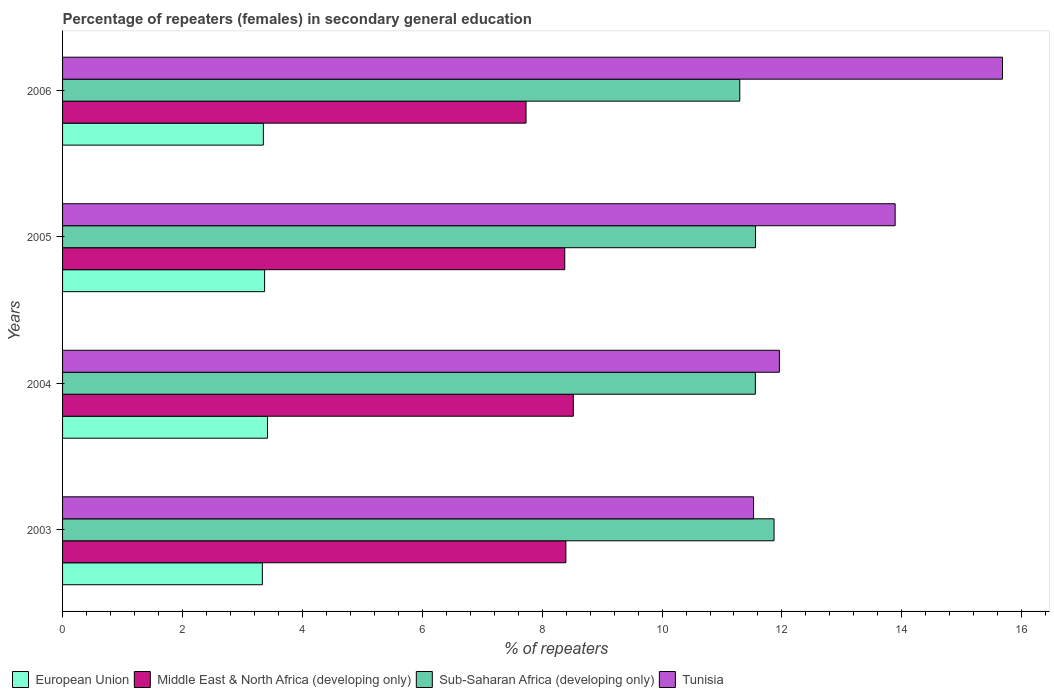How many groups of bars are there?
Keep it short and to the point. 4. How many bars are there on the 4th tick from the top?
Make the answer very short. 4. How many bars are there on the 2nd tick from the bottom?
Give a very brief answer. 4. What is the percentage of female repeaters in Tunisia in 2004?
Provide a short and direct response. 11.96. Across all years, what is the maximum percentage of female repeaters in European Union?
Your answer should be compact. 3.42. Across all years, what is the minimum percentage of female repeaters in Middle East & North Africa (developing only)?
Provide a succinct answer. 7.73. In which year was the percentage of female repeaters in Tunisia minimum?
Provide a short and direct response. 2003. What is the total percentage of female repeaters in Middle East & North Africa (developing only) in the graph?
Offer a very short reply. 33.02. What is the difference between the percentage of female repeaters in Middle East & North Africa (developing only) in 2003 and that in 2005?
Your answer should be compact. 0.02. What is the difference between the percentage of female repeaters in European Union in 2005 and the percentage of female repeaters in Middle East & North Africa (developing only) in 2003?
Provide a succinct answer. -5.03. What is the average percentage of female repeaters in Tunisia per year?
Make the answer very short. 13.26. In the year 2003, what is the difference between the percentage of female repeaters in Sub-Saharan Africa (developing only) and percentage of female repeaters in European Union?
Offer a terse response. 8.54. In how many years, is the percentage of female repeaters in Sub-Saharan Africa (developing only) greater than 7.2 %?
Keep it short and to the point. 4. What is the ratio of the percentage of female repeaters in Tunisia in 2004 to that in 2006?
Ensure brevity in your answer.  0.76. What is the difference between the highest and the second highest percentage of female repeaters in Tunisia?
Provide a succinct answer. 1.79. What is the difference between the highest and the lowest percentage of female repeaters in Tunisia?
Provide a succinct answer. 4.15. In how many years, is the percentage of female repeaters in European Union greater than the average percentage of female repeaters in European Union taken over all years?
Offer a terse response. 2. Is the sum of the percentage of female repeaters in European Union in 2003 and 2006 greater than the maximum percentage of female repeaters in Tunisia across all years?
Provide a short and direct response. No. What does the 1st bar from the top in 2006 represents?
Keep it short and to the point. Tunisia. Is it the case that in every year, the sum of the percentage of female repeaters in European Union and percentage of female repeaters in Sub-Saharan Africa (developing only) is greater than the percentage of female repeaters in Tunisia?
Offer a terse response. No. How many years are there in the graph?
Give a very brief answer. 4. What is the difference between two consecutive major ticks on the X-axis?
Offer a terse response. 2. Are the values on the major ticks of X-axis written in scientific E-notation?
Your response must be concise. No. Does the graph contain any zero values?
Ensure brevity in your answer.  No. Does the graph contain grids?
Make the answer very short. No. How many legend labels are there?
Make the answer very short. 4. What is the title of the graph?
Make the answer very short. Percentage of repeaters (females) in secondary general education. What is the label or title of the X-axis?
Give a very brief answer. % of repeaters. What is the % of repeaters in European Union in 2003?
Offer a terse response. 3.33. What is the % of repeaters of Middle East & North Africa (developing only) in 2003?
Provide a short and direct response. 8.4. What is the % of repeaters in Sub-Saharan Africa (developing only) in 2003?
Your answer should be compact. 11.87. What is the % of repeaters of Tunisia in 2003?
Your answer should be very brief. 11.53. What is the % of repeaters of European Union in 2004?
Provide a short and direct response. 3.42. What is the % of repeaters in Middle East & North Africa (developing only) in 2004?
Offer a very short reply. 8.52. What is the % of repeaters of Sub-Saharan Africa (developing only) in 2004?
Your answer should be compact. 11.56. What is the % of repeaters in Tunisia in 2004?
Your answer should be very brief. 11.96. What is the % of repeaters of European Union in 2005?
Provide a short and direct response. 3.37. What is the % of repeaters of Middle East & North Africa (developing only) in 2005?
Provide a succinct answer. 8.38. What is the % of repeaters of Sub-Saharan Africa (developing only) in 2005?
Your answer should be compact. 11.56. What is the % of repeaters in Tunisia in 2005?
Provide a short and direct response. 13.89. What is the % of repeaters in European Union in 2006?
Make the answer very short. 3.35. What is the % of repeaters in Middle East & North Africa (developing only) in 2006?
Make the answer very short. 7.73. What is the % of repeaters of Sub-Saharan Africa (developing only) in 2006?
Ensure brevity in your answer.  11.3. What is the % of repeaters in Tunisia in 2006?
Offer a terse response. 15.68. Across all years, what is the maximum % of repeaters of European Union?
Your answer should be very brief. 3.42. Across all years, what is the maximum % of repeaters in Middle East & North Africa (developing only)?
Keep it short and to the point. 8.52. Across all years, what is the maximum % of repeaters of Sub-Saharan Africa (developing only)?
Provide a succinct answer. 11.87. Across all years, what is the maximum % of repeaters in Tunisia?
Make the answer very short. 15.68. Across all years, what is the minimum % of repeaters of European Union?
Provide a succinct answer. 3.33. Across all years, what is the minimum % of repeaters of Middle East & North Africa (developing only)?
Your answer should be very brief. 7.73. Across all years, what is the minimum % of repeaters of Sub-Saharan Africa (developing only)?
Your response must be concise. 11.3. Across all years, what is the minimum % of repeaters of Tunisia?
Provide a short and direct response. 11.53. What is the total % of repeaters in European Union in the graph?
Make the answer very short. 13.47. What is the total % of repeaters in Middle East & North Africa (developing only) in the graph?
Provide a succinct answer. 33.02. What is the total % of repeaters of Sub-Saharan Africa (developing only) in the graph?
Your answer should be compact. 46.28. What is the total % of repeaters of Tunisia in the graph?
Make the answer very short. 53.05. What is the difference between the % of repeaters of European Union in 2003 and that in 2004?
Offer a terse response. -0.09. What is the difference between the % of repeaters of Middle East & North Africa (developing only) in 2003 and that in 2004?
Your answer should be very brief. -0.12. What is the difference between the % of repeaters in Sub-Saharan Africa (developing only) in 2003 and that in 2004?
Your response must be concise. 0.31. What is the difference between the % of repeaters in Tunisia in 2003 and that in 2004?
Your response must be concise. -0.43. What is the difference between the % of repeaters in European Union in 2003 and that in 2005?
Keep it short and to the point. -0.04. What is the difference between the % of repeaters in Middle East & North Africa (developing only) in 2003 and that in 2005?
Ensure brevity in your answer.  0.02. What is the difference between the % of repeaters in Sub-Saharan Africa (developing only) in 2003 and that in 2005?
Offer a terse response. 0.31. What is the difference between the % of repeaters in Tunisia in 2003 and that in 2005?
Your answer should be compact. -2.36. What is the difference between the % of repeaters in European Union in 2003 and that in 2006?
Give a very brief answer. -0.02. What is the difference between the % of repeaters in Middle East & North Africa (developing only) in 2003 and that in 2006?
Keep it short and to the point. 0.66. What is the difference between the % of repeaters in Sub-Saharan Africa (developing only) in 2003 and that in 2006?
Provide a short and direct response. 0.57. What is the difference between the % of repeaters of Tunisia in 2003 and that in 2006?
Make the answer very short. -4.15. What is the difference between the % of repeaters of European Union in 2004 and that in 2005?
Provide a short and direct response. 0.05. What is the difference between the % of repeaters in Middle East & North Africa (developing only) in 2004 and that in 2005?
Provide a succinct answer. 0.14. What is the difference between the % of repeaters in Sub-Saharan Africa (developing only) in 2004 and that in 2005?
Your response must be concise. -0. What is the difference between the % of repeaters of Tunisia in 2004 and that in 2005?
Your answer should be compact. -1.93. What is the difference between the % of repeaters in European Union in 2004 and that in 2006?
Give a very brief answer. 0.07. What is the difference between the % of repeaters of Middle East & North Africa (developing only) in 2004 and that in 2006?
Ensure brevity in your answer.  0.79. What is the difference between the % of repeaters of Sub-Saharan Africa (developing only) in 2004 and that in 2006?
Your answer should be very brief. 0.26. What is the difference between the % of repeaters in Tunisia in 2004 and that in 2006?
Keep it short and to the point. -3.72. What is the difference between the % of repeaters of European Union in 2005 and that in 2006?
Ensure brevity in your answer.  0.02. What is the difference between the % of repeaters in Middle East & North Africa (developing only) in 2005 and that in 2006?
Ensure brevity in your answer.  0.65. What is the difference between the % of repeaters of Sub-Saharan Africa (developing only) in 2005 and that in 2006?
Your answer should be compact. 0.26. What is the difference between the % of repeaters of Tunisia in 2005 and that in 2006?
Offer a terse response. -1.79. What is the difference between the % of repeaters of European Union in 2003 and the % of repeaters of Middle East & North Africa (developing only) in 2004?
Your answer should be very brief. -5.19. What is the difference between the % of repeaters in European Union in 2003 and the % of repeaters in Sub-Saharan Africa (developing only) in 2004?
Provide a succinct answer. -8.22. What is the difference between the % of repeaters of European Union in 2003 and the % of repeaters of Tunisia in 2004?
Your answer should be very brief. -8.62. What is the difference between the % of repeaters in Middle East & North Africa (developing only) in 2003 and the % of repeaters in Sub-Saharan Africa (developing only) in 2004?
Make the answer very short. -3.16. What is the difference between the % of repeaters in Middle East & North Africa (developing only) in 2003 and the % of repeaters in Tunisia in 2004?
Offer a terse response. -3.56. What is the difference between the % of repeaters in Sub-Saharan Africa (developing only) in 2003 and the % of repeaters in Tunisia in 2004?
Offer a very short reply. -0.09. What is the difference between the % of repeaters in European Union in 2003 and the % of repeaters in Middle East & North Africa (developing only) in 2005?
Provide a succinct answer. -5.04. What is the difference between the % of repeaters in European Union in 2003 and the % of repeaters in Sub-Saharan Africa (developing only) in 2005?
Provide a succinct answer. -8.23. What is the difference between the % of repeaters in European Union in 2003 and the % of repeaters in Tunisia in 2005?
Make the answer very short. -10.56. What is the difference between the % of repeaters in Middle East & North Africa (developing only) in 2003 and the % of repeaters in Sub-Saharan Africa (developing only) in 2005?
Your answer should be very brief. -3.16. What is the difference between the % of repeaters in Middle East & North Africa (developing only) in 2003 and the % of repeaters in Tunisia in 2005?
Make the answer very short. -5.49. What is the difference between the % of repeaters in Sub-Saharan Africa (developing only) in 2003 and the % of repeaters in Tunisia in 2005?
Your response must be concise. -2.02. What is the difference between the % of repeaters of European Union in 2003 and the % of repeaters of Middle East & North Africa (developing only) in 2006?
Offer a very short reply. -4.4. What is the difference between the % of repeaters of European Union in 2003 and the % of repeaters of Sub-Saharan Africa (developing only) in 2006?
Give a very brief answer. -7.96. What is the difference between the % of repeaters of European Union in 2003 and the % of repeaters of Tunisia in 2006?
Provide a succinct answer. -12.35. What is the difference between the % of repeaters of Middle East & North Africa (developing only) in 2003 and the % of repeaters of Sub-Saharan Africa (developing only) in 2006?
Keep it short and to the point. -2.9. What is the difference between the % of repeaters of Middle East & North Africa (developing only) in 2003 and the % of repeaters of Tunisia in 2006?
Provide a short and direct response. -7.28. What is the difference between the % of repeaters in Sub-Saharan Africa (developing only) in 2003 and the % of repeaters in Tunisia in 2006?
Give a very brief answer. -3.81. What is the difference between the % of repeaters of European Union in 2004 and the % of repeaters of Middle East & North Africa (developing only) in 2005?
Your answer should be very brief. -4.96. What is the difference between the % of repeaters of European Union in 2004 and the % of repeaters of Sub-Saharan Africa (developing only) in 2005?
Provide a short and direct response. -8.14. What is the difference between the % of repeaters in European Union in 2004 and the % of repeaters in Tunisia in 2005?
Ensure brevity in your answer.  -10.47. What is the difference between the % of repeaters of Middle East & North Africa (developing only) in 2004 and the % of repeaters of Sub-Saharan Africa (developing only) in 2005?
Your answer should be compact. -3.04. What is the difference between the % of repeaters of Middle East & North Africa (developing only) in 2004 and the % of repeaters of Tunisia in 2005?
Keep it short and to the point. -5.37. What is the difference between the % of repeaters of Sub-Saharan Africa (developing only) in 2004 and the % of repeaters of Tunisia in 2005?
Keep it short and to the point. -2.33. What is the difference between the % of repeaters in European Union in 2004 and the % of repeaters in Middle East & North Africa (developing only) in 2006?
Give a very brief answer. -4.31. What is the difference between the % of repeaters of European Union in 2004 and the % of repeaters of Sub-Saharan Africa (developing only) in 2006?
Make the answer very short. -7.88. What is the difference between the % of repeaters of European Union in 2004 and the % of repeaters of Tunisia in 2006?
Provide a succinct answer. -12.26. What is the difference between the % of repeaters in Middle East & North Africa (developing only) in 2004 and the % of repeaters in Sub-Saharan Africa (developing only) in 2006?
Your answer should be compact. -2.78. What is the difference between the % of repeaters of Middle East & North Africa (developing only) in 2004 and the % of repeaters of Tunisia in 2006?
Provide a short and direct response. -7.16. What is the difference between the % of repeaters of Sub-Saharan Africa (developing only) in 2004 and the % of repeaters of Tunisia in 2006?
Offer a terse response. -4.12. What is the difference between the % of repeaters of European Union in 2005 and the % of repeaters of Middle East & North Africa (developing only) in 2006?
Ensure brevity in your answer.  -4.36. What is the difference between the % of repeaters in European Union in 2005 and the % of repeaters in Sub-Saharan Africa (developing only) in 2006?
Ensure brevity in your answer.  -7.93. What is the difference between the % of repeaters in European Union in 2005 and the % of repeaters in Tunisia in 2006?
Provide a short and direct response. -12.31. What is the difference between the % of repeaters of Middle East & North Africa (developing only) in 2005 and the % of repeaters of Sub-Saharan Africa (developing only) in 2006?
Your response must be concise. -2.92. What is the difference between the % of repeaters in Middle East & North Africa (developing only) in 2005 and the % of repeaters in Tunisia in 2006?
Provide a short and direct response. -7.3. What is the difference between the % of repeaters in Sub-Saharan Africa (developing only) in 2005 and the % of repeaters in Tunisia in 2006?
Your answer should be compact. -4.12. What is the average % of repeaters of European Union per year?
Provide a short and direct response. 3.37. What is the average % of repeaters of Middle East & North Africa (developing only) per year?
Provide a short and direct response. 8.26. What is the average % of repeaters of Sub-Saharan Africa (developing only) per year?
Provide a succinct answer. 11.57. What is the average % of repeaters in Tunisia per year?
Your response must be concise. 13.26. In the year 2003, what is the difference between the % of repeaters of European Union and % of repeaters of Middle East & North Africa (developing only)?
Keep it short and to the point. -5.06. In the year 2003, what is the difference between the % of repeaters of European Union and % of repeaters of Sub-Saharan Africa (developing only)?
Offer a terse response. -8.54. In the year 2003, what is the difference between the % of repeaters of European Union and % of repeaters of Tunisia?
Keep it short and to the point. -8.19. In the year 2003, what is the difference between the % of repeaters of Middle East & North Africa (developing only) and % of repeaters of Sub-Saharan Africa (developing only)?
Your answer should be very brief. -3.47. In the year 2003, what is the difference between the % of repeaters in Middle East & North Africa (developing only) and % of repeaters in Tunisia?
Give a very brief answer. -3.13. In the year 2003, what is the difference between the % of repeaters of Sub-Saharan Africa (developing only) and % of repeaters of Tunisia?
Ensure brevity in your answer.  0.34. In the year 2004, what is the difference between the % of repeaters of European Union and % of repeaters of Middle East & North Africa (developing only)?
Your response must be concise. -5.1. In the year 2004, what is the difference between the % of repeaters in European Union and % of repeaters in Sub-Saharan Africa (developing only)?
Make the answer very short. -8.14. In the year 2004, what is the difference between the % of repeaters in European Union and % of repeaters in Tunisia?
Your response must be concise. -8.54. In the year 2004, what is the difference between the % of repeaters in Middle East & North Africa (developing only) and % of repeaters in Sub-Saharan Africa (developing only)?
Provide a short and direct response. -3.04. In the year 2004, what is the difference between the % of repeaters of Middle East & North Africa (developing only) and % of repeaters of Tunisia?
Your answer should be compact. -3.44. In the year 2004, what is the difference between the % of repeaters in Sub-Saharan Africa (developing only) and % of repeaters in Tunisia?
Your answer should be very brief. -0.4. In the year 2005, what is the difference between the % of repeaters of European Union and % of repeaters of Middle East & North Africa (developing only)?
Offer a terse response. -5.01. In the year 2005, what is the difference between the % of repeaters in European Union and % of repeaters in Sub-Saharan Africa (developing only)?
Give a very brief answer. -8.19. In the year 2005, what is the difference between the % of repeaters in European Union and % of repeaters in Tunisia?
Give a very brief answer. -10.52. In the year 2005, what is the difference between the % of repeaters in Middle East & North Africa (developing only) and % of repeaters in Sub-Saharan Africa (developing only)?
Your answer should be very brief. -3.18. In the year 2005, what is the difference between the % of repeaters of Middle East & North Africa (developing only) and % of repeaters of Tunisia?
Provide a short and direct response. -5.51. In the year 2005, what is the difference between the % of repeaters of Sub-Saharan Africa (developing only) and % of repeaters of Tunisia?
Provide a succinct answer. -2.33. In the year 2006, what is the difference between the % of repeaters of European Union and % of repeaters of Middle East & North Africa (developing only)?
Give a very brief answer. -4.38. In the year 2006, what is the difference between the % of repeaters in European Union and % of repeaters in Sub-Saharan Africa (developing only)?
Make the answer very short. -7.95. In the year 2006, what is the difference between the % of repeaters in European Union and % of repeaters in Tunisia?
Provide a succinct answer. -12.33. In the year 2006, what is the difference between the % of repeaters in Middle East & North Africa (developing only) and % of repeaters in Sub-Saharan Africa (developing only)?
Your answer should be compact. -3.56. In the year 2006, what is the difference between the % of repeaters of Middle East & North Africa (developing only) and % of repeaters of Tunisia?
Provide a short and direct response. -7.95. In the year 2006, what is the difference between the % of repeaters in Sub-Saharan Africa (developing only) and % of repeaters in Tunisia?
Your answer should be compact. -4.38. What is the ratio of the % of repeaters in European Union in 2003 to that in 2004?
Provide a short and direct response. 0.97. What is the ratio of the % of repeaters of Middle East & North Africa (developing only) in 2003 to that in 2004?
Provide a short and direct response. 0.99. What is the ratio of the % of repeaters in Tunisia in 2003 to that in 2004?
Keep it short and to the point. 0.96. What is the ratio of the % of repeaters in European Union in 2003 to that in 2005?
Offer a very short reply. 0.99. What is the ratio of the % of repeaters in Middle East & North Africa (developing only) in 2003 to that in 2005?
Provide a short and direct response. 1. What is the ratio of the % of repeaters of Sub-Saharan Africa (developing only) in 2003 to that in 2005?
Give a very brief answer. 1.03. What is the ratio of the % of repeaters in Tunisia in 2003 to that in 2005?
Your answer should be compact. 0.83. What is the ratio of the % of repeaters of European Union in 2003 to that in 2006?
Your answer should be very brief. 1. What is the ratio of the % of repeaters of Middle East & North Africa (developing only) in 2003 to that in 2006?
Provide a short and direct response. 1.09. What is the ratio of the % of repeaters in Sub-Saharan Africa (developing only) in 2003 to that in 2006?
Ensure brevity in your answer.  1.05. What is the ratio of the % of repeaters in Tunisia in 2003 to that in 2006?
Offer a terse response. 0.74. What is the ratio of the % of repeaters in European Union in 2004 to that in 2005?
Keep it short and to the point. 1.01. What is the ratio of the % of repeaters in Tunisia in 2004 to that in 2005?
Keep it short and to the point. 0.86. What is the ratio of the % of repeaters in European Union in 2004 to that in 2006?
Your response must be concise. 1.02. What is the ratio of the % of repeaters of Middle East & North Africa (developing only) in 2004 to that in 2006?
Offer a terse response. 1.1. What is the ratio of the % of repeaters of Sub-Saharan Africa (developing only) in 2004 to that in 2006?
Make the answer very short. 1.02. What is the ratio of the % of repeaters of Tunisia in 2004 to that in 2006?
Offer a very short reply. 0.76. What is the ratio of the % of repeaters in European Union in 2005 to that in 2006?
Offer a terse response. 1.01. What is the ratio of the % of repeaters of Middle East & North Africa (developing only) in 2005 to that in 2006?
Offer a terse response. 1.08. What is the ratio of the % of repeaters of Sub-Saharan Africa (developing only) in 2005 to that in 2006?
Keep it short and to the point. 1.02. What is the ratio of the % of repeaters of Tunisia in 2005 to that in 2006?
Provide a short and direct response. 0.89. What is the difference between the highest and the second highest % of repeaters in European Union?
Your response must be concise. 0.05. What is the difference between the highest and the second highest % of repeaters of Middle East & North Africa (developing only)?
Your answer should be very brief. 0.12. What is the difference between the highest and the second highest % of repeaters in Sub-Saharan Africa (developing only)?
Your answer should be compact. 0.31. What is the difference between the highest and the second highest % of repeaters of Tunisia?
Offer a very short reply. 1.79. What is the difference between the highest and the lowest % of repeaters of European Union?
Make the answer very short. 0.09. What is the difference between the highest and the lowest % of repeaters of Middle East & North Africa (developing only)?
Your answer should be compact. 0.79. What is the difference between the highest and the lowest % of repeaters of Sub-Saharan Africa (developing only)?
Ensure brevity in your answer.  0.57. What is the difference between the highest and the lowest % of repeaters in Tunisia?
Give a very brief answer. 4.15. 